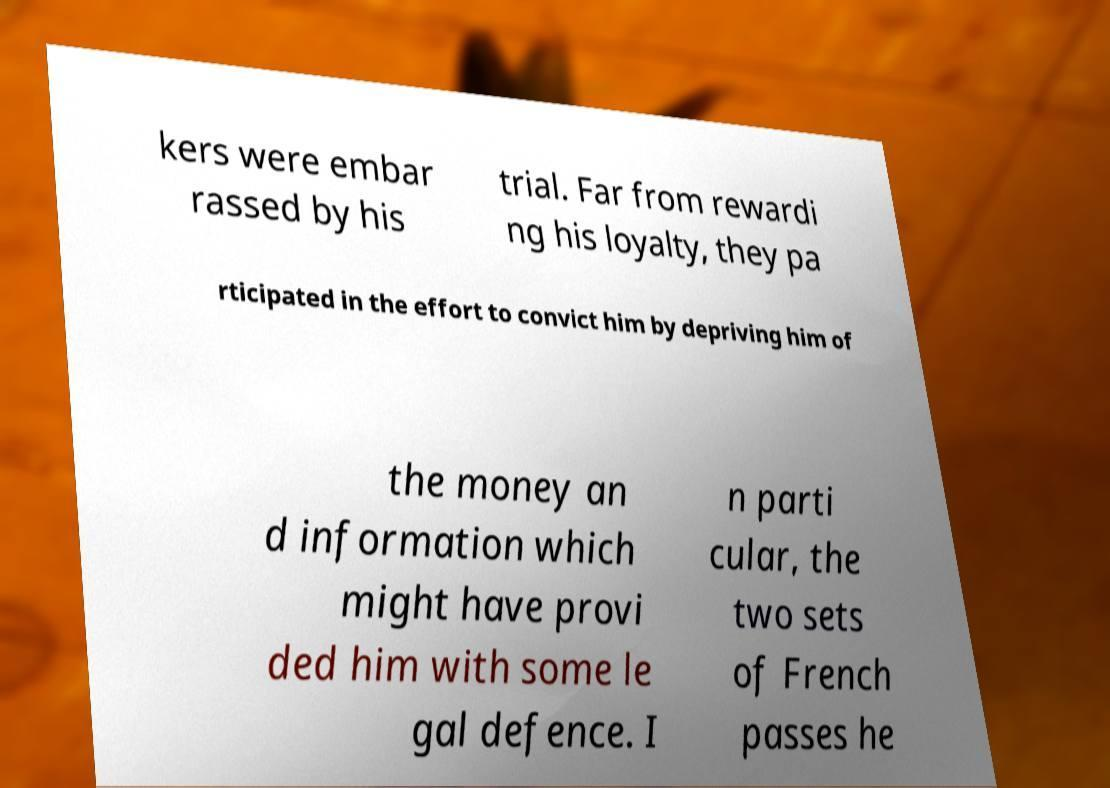I need the written content from this picture converted into text. Can you do that? kers were embar rassed by his trial. Far from rewardi ng his loyalty, they pa rticipated in the effort to convict him by depriving him of the money an d information which might have provi ded him with some le gal defence. I n parti cular, the two sets of French passes he 